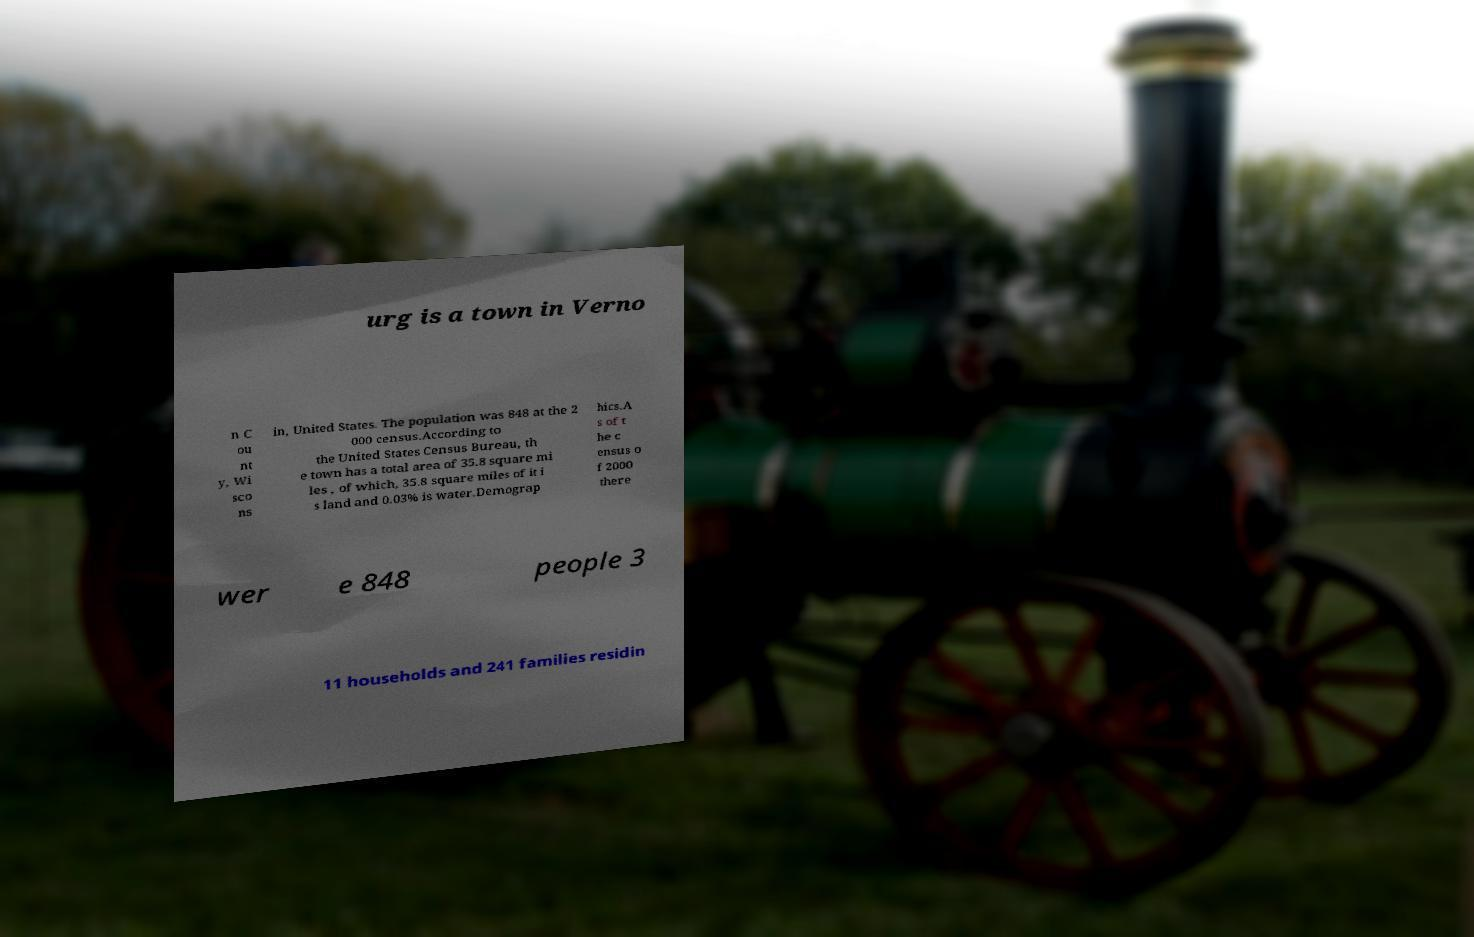Could you extract and type out the text from this image? urg is a town in Verno n C ou nt y, Wi sco ns in, United States. The population was 848 at the 2 000 census.According to the United States Census Bureau, th e town has a total area of 35.8 square mi les , of which, 35.8 square miles of it i s land and 0.03% is water.Demograp hics.A s of t he c ensus o f 2000 there wer e 848 people 3 11 households and 241 families residin 